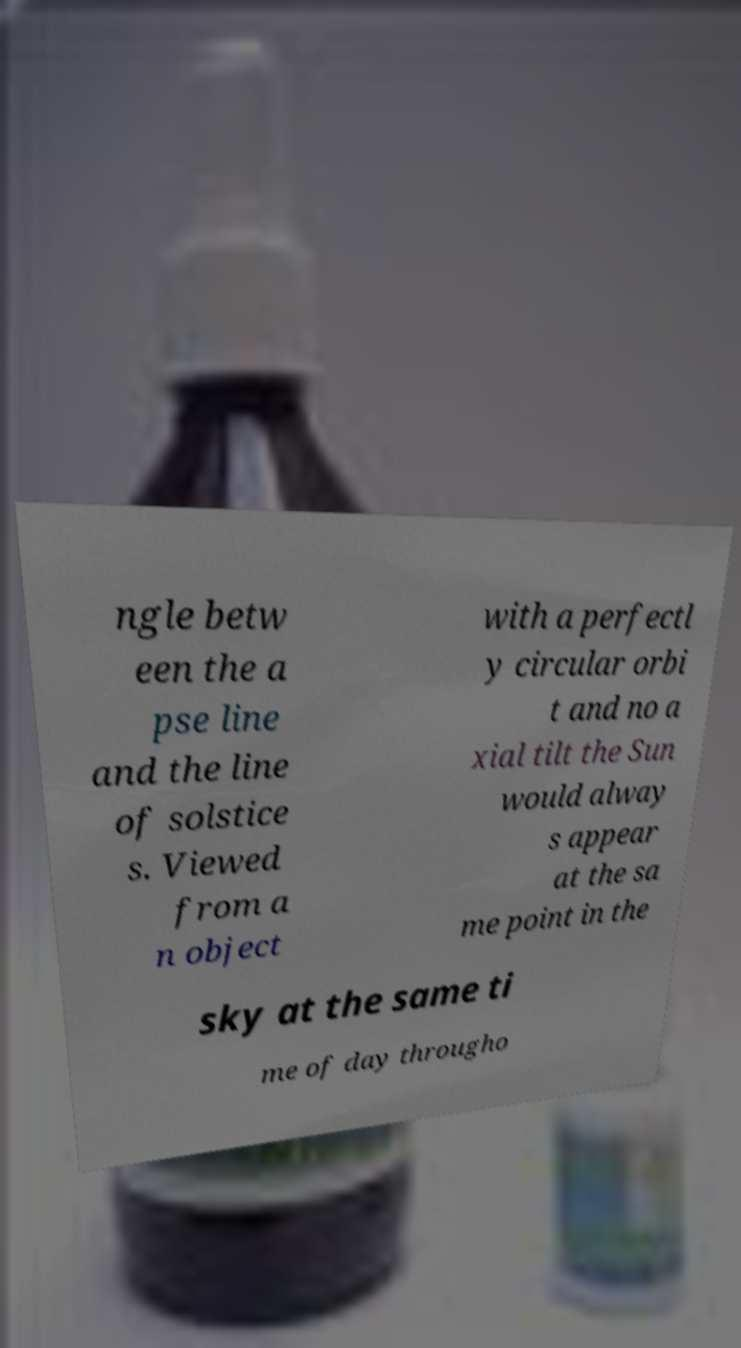Could you assist in decoding the text presented in this image and type it out clearly? ngle betw een the a pse line and the line of solstice s. Viewed from a n object with a perfectl y circular orbi t and no a xial tilt the Sun would alway s appear at the sa me point in the sky at the same ti me of day througho 